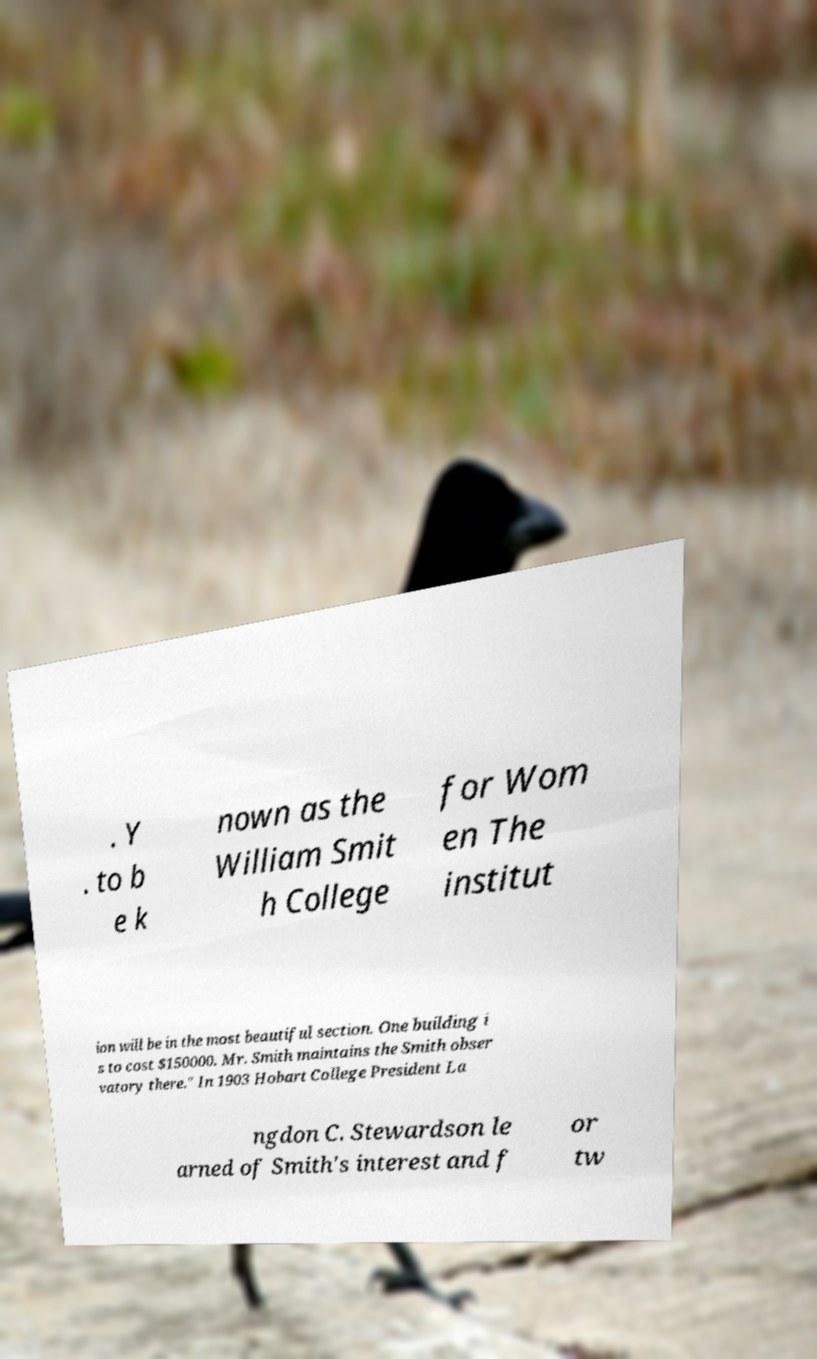Please identify and transcribe the text found in this image. . Y . to b e k nown as the William Smit h College for Wom en The institut ion will be in the most beautiful section. One building i s to cost $150000. Mr. Smith maintains the Smith obser vatory there." In 1903 Hobart College President La ngdon C. Stewardson le arned of Smith's interest and f or tw 